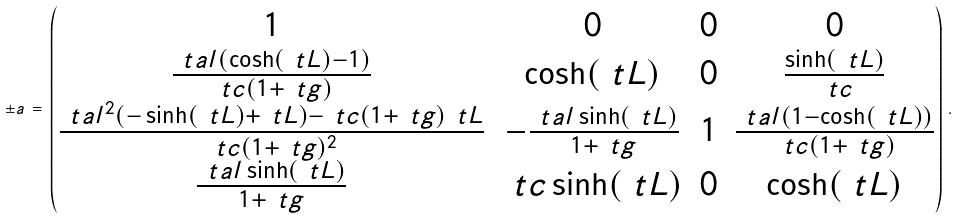<formula> <loc_0><loc_0><loc_500><loc_500>\pm a \, = \, \begin{pmatrix} 1 & 0 & 0 & 0 \\ \frac { \ t a l ( \cosh ( \ t L ) - 1 ) } { \ t c ( 1 + \ t g ) } & \cosh ( \ t L ) & 0 & \frac { \sinh ( \ t L ) } { \ t c } \\ \frac { \ t a l ^ { 2 } ( - \sinh ( \ t L ) + \ t L ) - \ t c ( 1 + \ t g ) \ t L } { \ t c ( 1 + \ t g ) ^ { 2 } } & - \frac { \ t a l \sinh ( \ t L ) } { 1 + \ t g } & 1 & \frac { \ t a l ( 1 - \cosh ( \ t L ) ) } { \ t c ( 1 + \ t g ) } \\ \frac { \ t a l \sinh ( \ t L ) } { 1 + \ t g } & \ t c \sinh ( \ t L ) & 0 & \cosh ( \ t L ) \end{pmatrix} \, .</formula> 